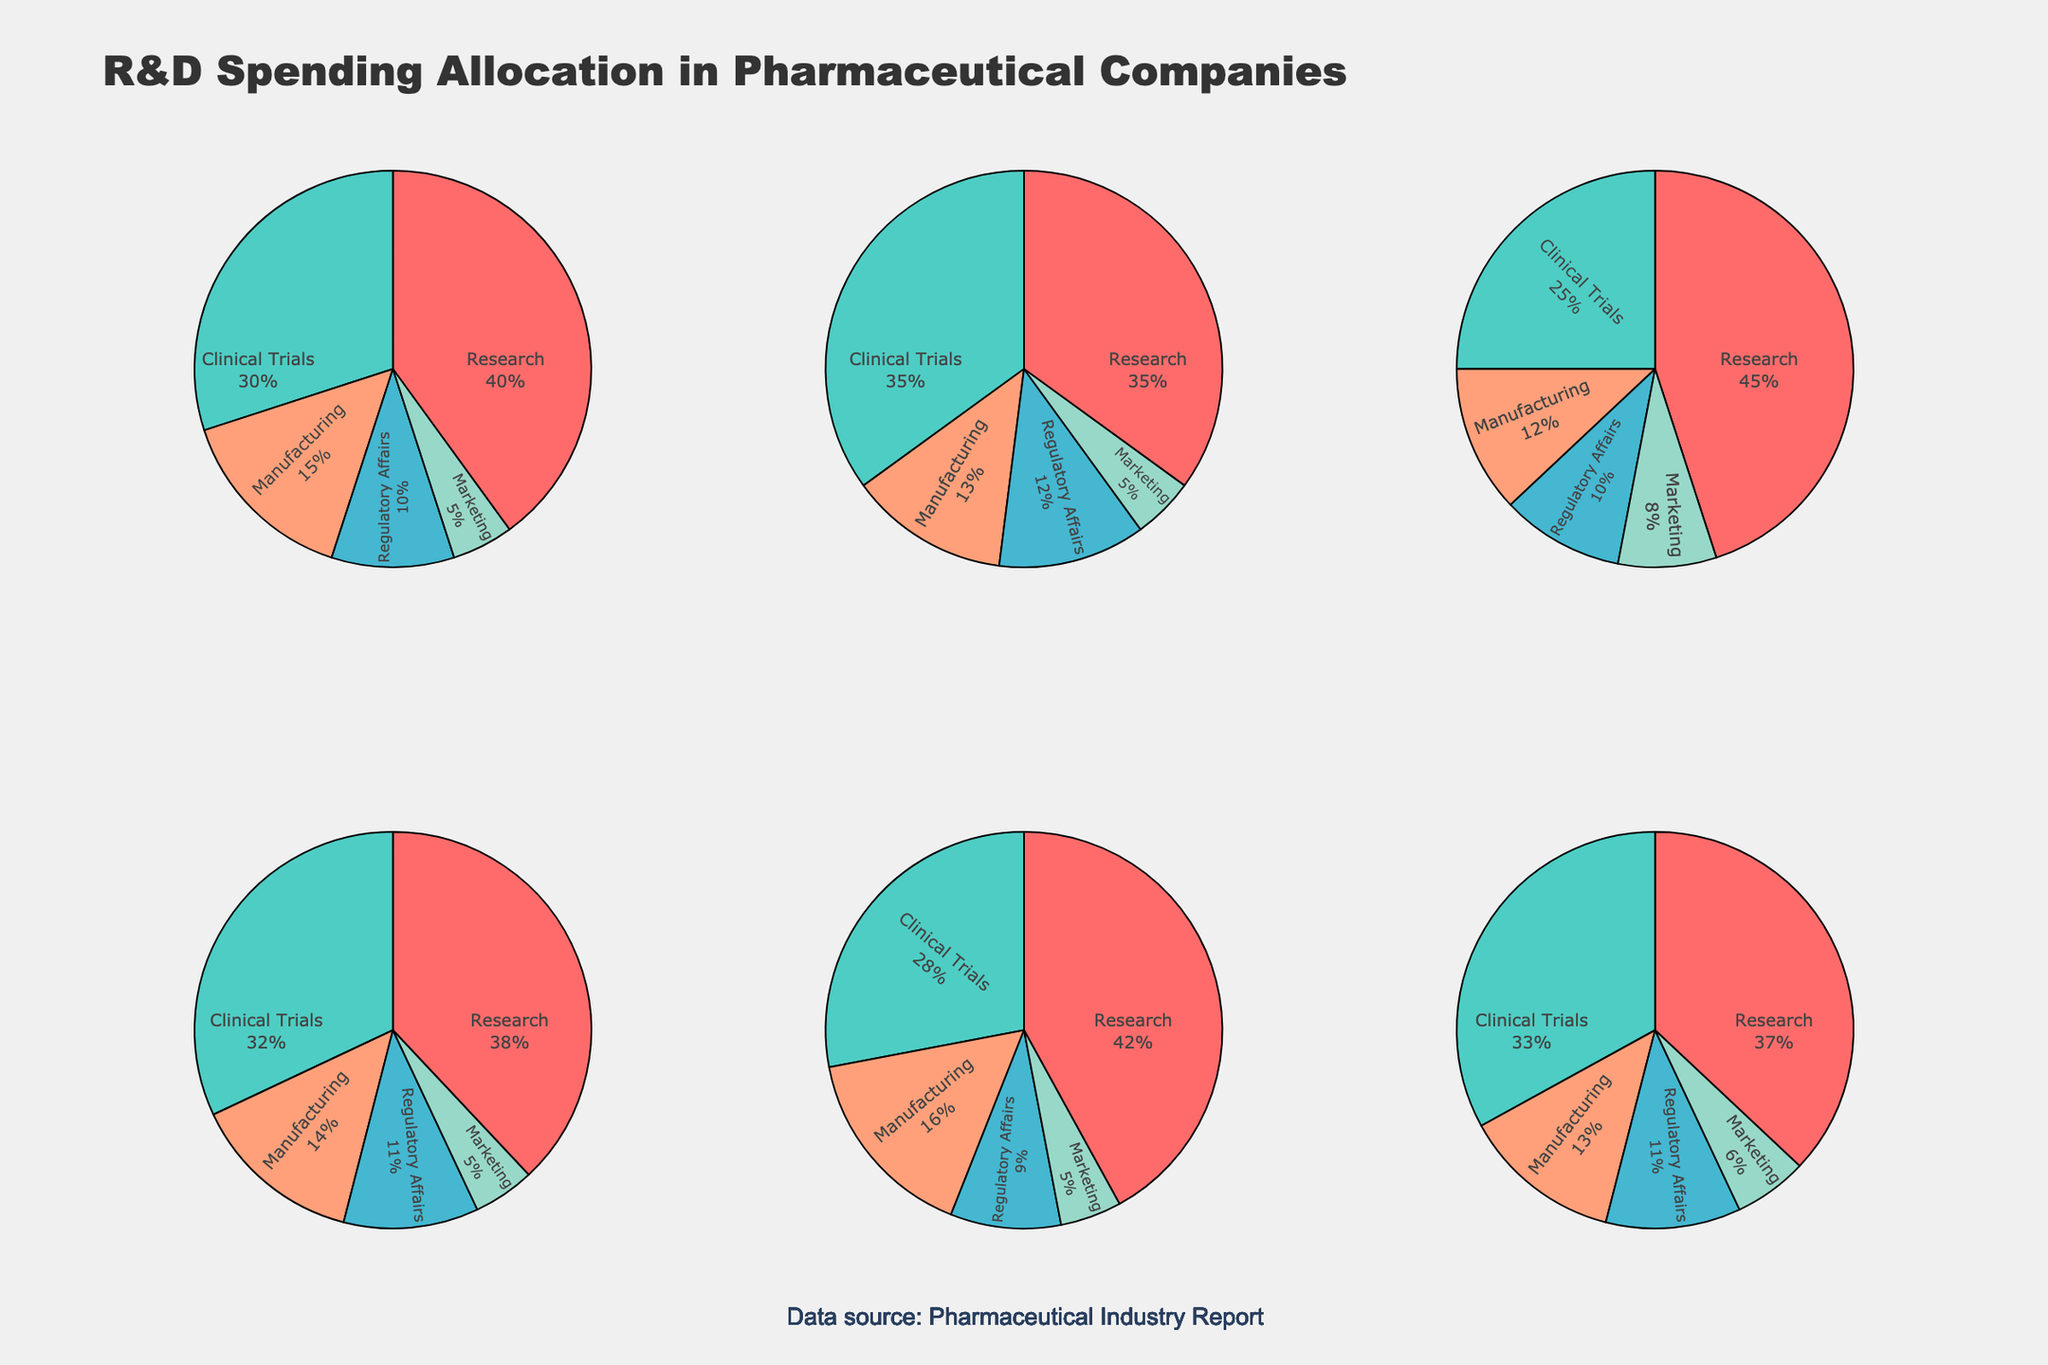What is the title of the figure? The title of the figure is found at the top and provides an overview of what the figure represents. In this case, the title describes the allocation of R&D spending among different departments in pharmaceutical companies.
Answer: "R&D Spending Allocation in Pharmaceutical Companies" Which department has the smallest allocation percentage in Pfizer? Looking at Pfizer's pie chart, identify the smallest sector and check its label or percentage indication to find the smallest allocation.
Answer: Marketing How much percentage of R&D spending does Novartis allocate to Clinical Trials and Manufacturing combined? Look at Novartis's pie chart. Find the percentage for Clinical Trials (35%) and Manufacturing (13%), then add them together: 35% + 13% = 48%
Answer: 48% Which company allocates the highest percentage to Research? Inspect the pie charts for each company, focusing on the Research section, and determine which company allocates the highest percentage. Roche allocates the highest at 45%.
Answer: Roche What is the difference in R&D spending allocation percentage for Regulatory Affairs between Johnson & Johnson and Merck? Check the percentages allocated for Regulatory Affairs from the pie charts for Johnson & Johnson (9%) and Merck (11%), then find their difference: 11% - 9% = 2%
Answer: 2% How does the allocation to Marketing in Roche compare to that in GlaxoSmithKline? Identify the Marketing percentages in the pie charts for Roche (8%) and GlaxoSmithKline (6%). Compare the two values to see which is larger or if they are equal. Roche allocates 2% more to Marketing than GlaxoSmithKline.
Answer: Roche allocates more What percentage of R&D spending does Merck allocate to departments other than Research? Find the percentage for Research in Merck which is 38%, then subtract this from 100% to find the combined spending on other departments: 100% - 38% = 62%
Answer: 62% Are there any companies that allocate more than 30% of their R&D spending to Clinical Trials? Examine each pie chart for the percentage allocated to Clinical Trials, and list the companies with over 30%. Novartis, Merck, and GlaxoSmithKline allocate more than 30% to Clinical Trials.
Answer: Novartis, Merck, GlaxoSmithKline 